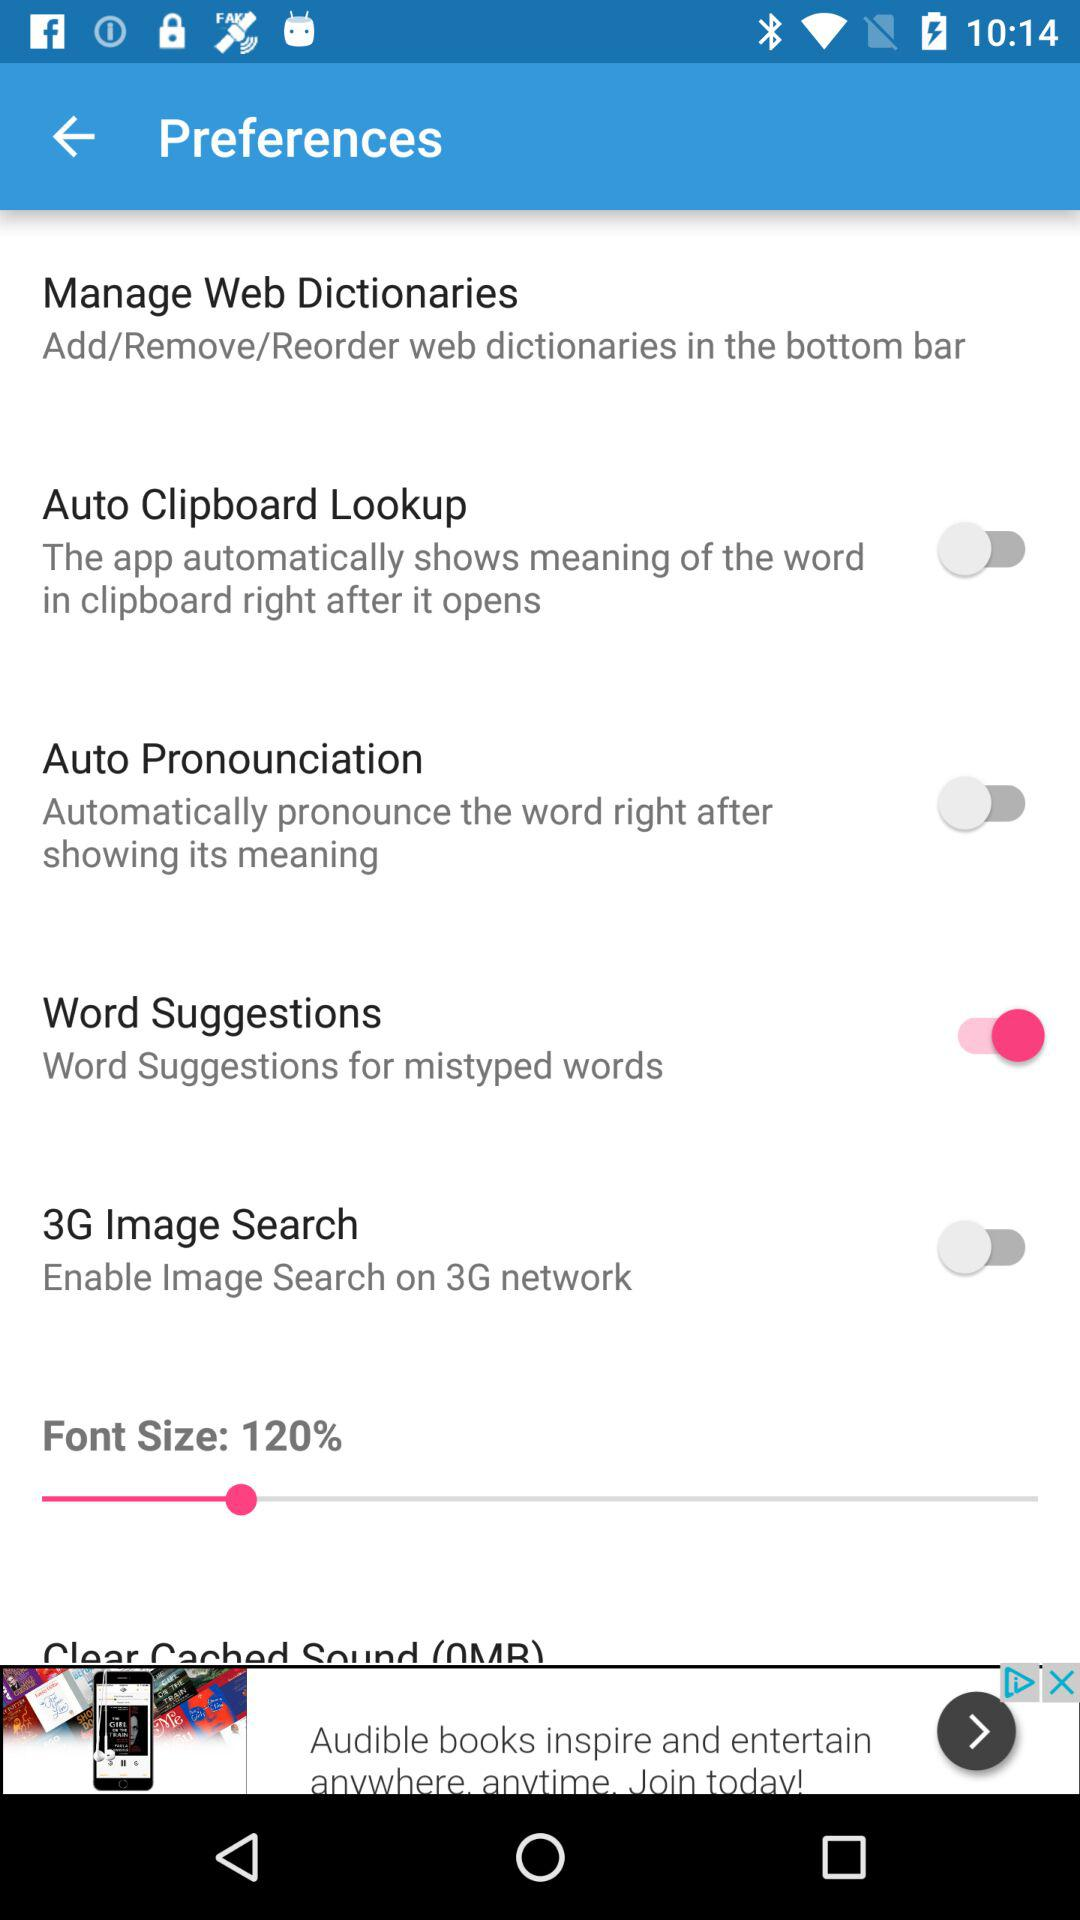What is the current status of the "Word Suggestions" settings? The current status is "on". 